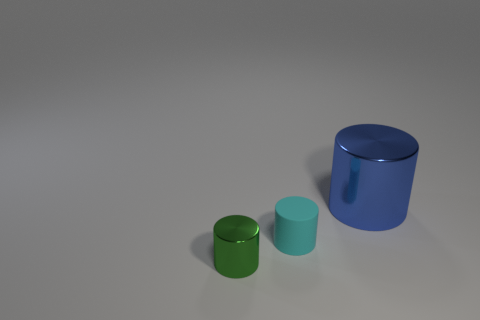Add 3 small metallic cylinders. How many objects exist? 6 Subtract 0 brown blocks. How many objects are left? 3 Subtract all small gray blocks. Subtract all shiny cylinders. How many objects are left? 1 Add 2 cyan cylinders. How many cyan cylinders are left? 3 Add 2 rubber cylinders. How many rubber cylinders exist? 3 